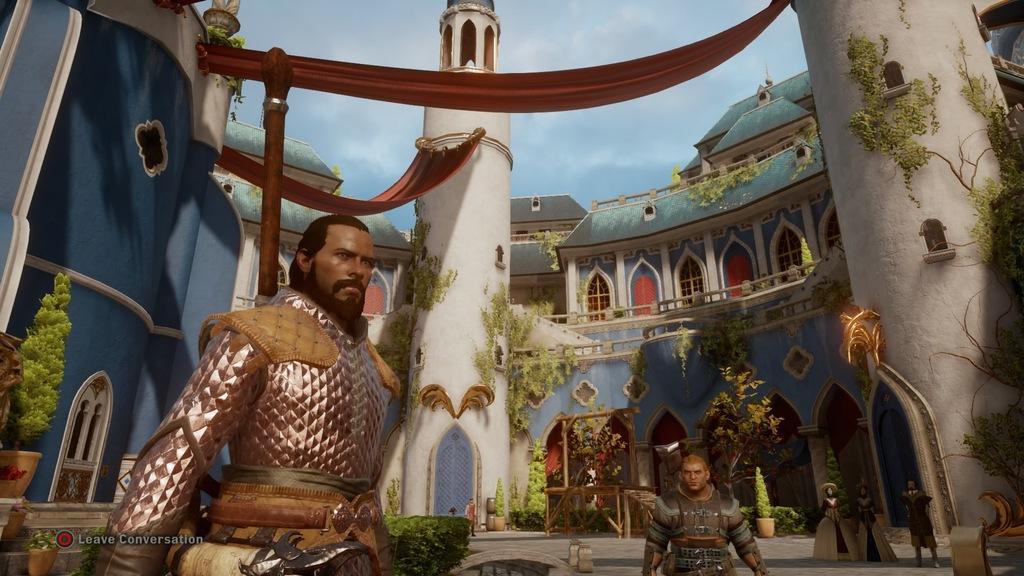Please provide a concise description of this image. In this picture I can see animated image. I can see people. I can see the house. I can see plant pots. 